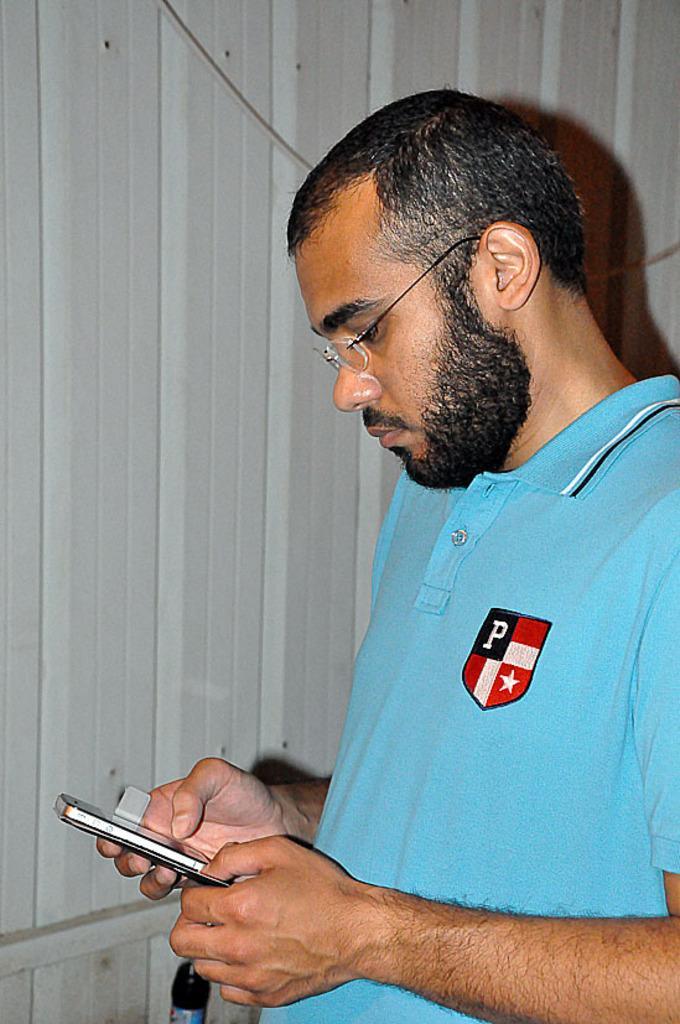Describe this image in one or two sentences. Man is wearing a blue t shirt and spectacles. And is holding a mobile and he is looking it. Back of him there is a wall. 